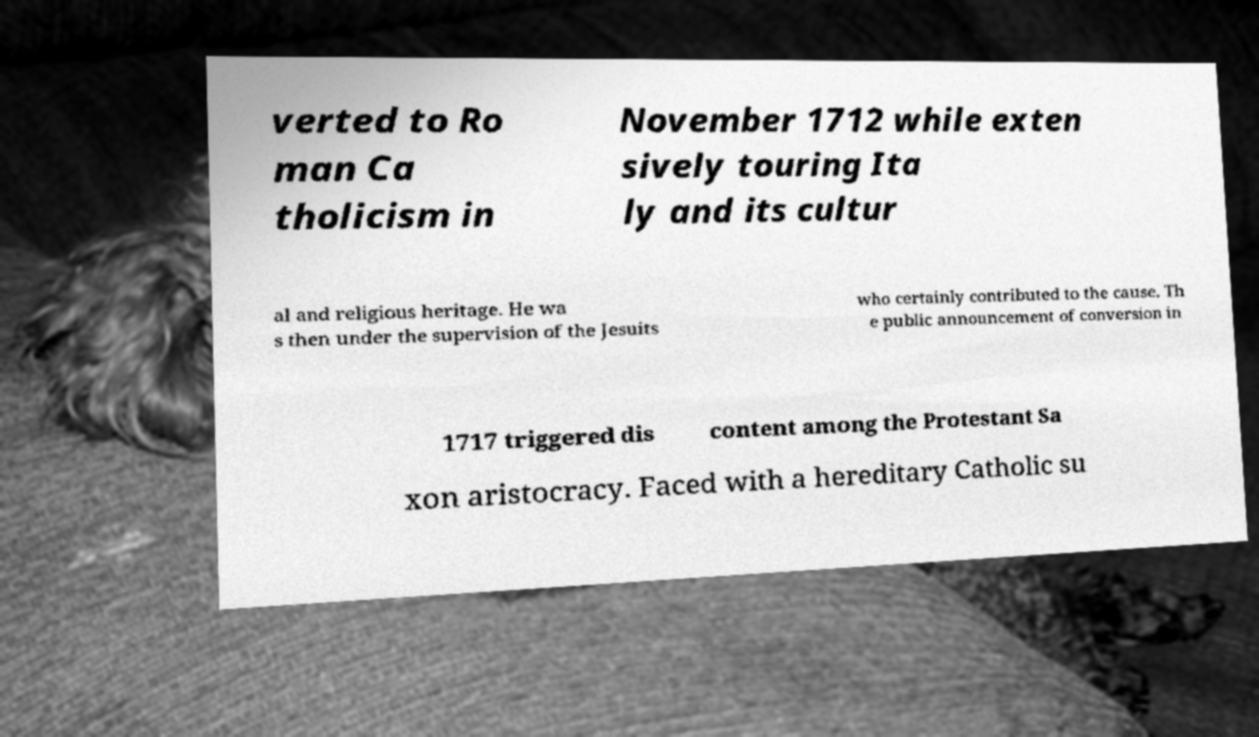Could you extract and type out the text from this image? verted to Ro man Ca tholicism in November 1712 while exten sively touring Ita ly and its cultur al and religious heritage. He wa s then under the supervision of the Jesuits who certainly contributed to the cause. Th e public announcement of conversion in 1717 triggered dis content among the Protestant Sa xon aristocracy. Faced with a hereditary Catholic su 